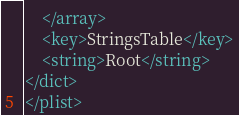Convert code to text. <code><loc_0><loc_0><loc_500><loc_500><_XML_>	</array>
	<key>StringsTable</key>
	<string>Root</string>
</dict>
</plist>
</code> 